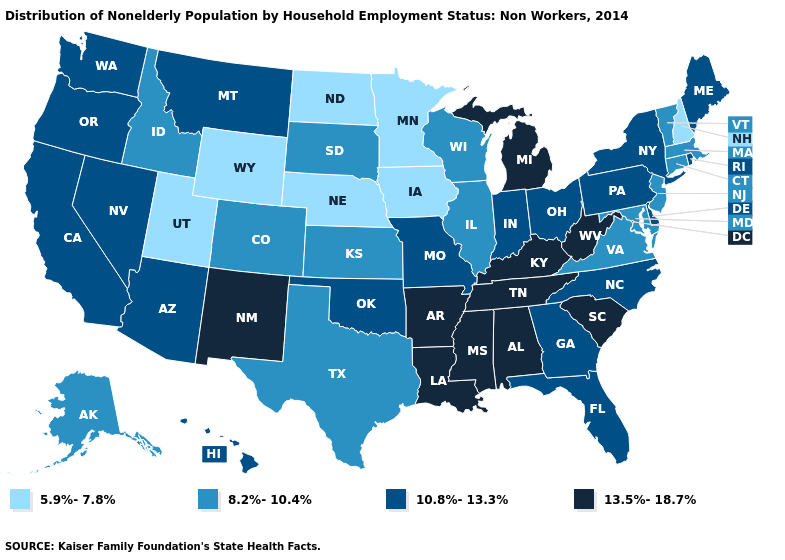Does Delaware have the same value as Arkansas?
Short answer required. No. Which states have the highest value in the USA?
Short answer required. Alabama, Arkansas, Kentucky, Louisiana, Michigan, Mississippi, New Mexico, South Carolina, Tennessee, West Virginia. Does Mississippi have the highest value in the USA?
Quick response, please. Yes. What is the highest value in the USA?
Concise answer only. 13.5%-18.7%. Does the first symbol in the legend represent the smallest category?
Be succinct. Yes. Name the states that have a value in the range 13.5%-18.7%?
Be succinct. Alabama, Arkansas, Kentucky, Louisiana, Michigan, Mississippi, New Mexico, South Carolina, Tennessee, West Virginia. Among the states that border Michigan , which have the highest value?
Write a very short answer. Indiana, Ohio. What is the lowest value in the USA?
Short answer required. 5.9%-7.8%. Name the states that have a value in the range 13.5%-18.7%?
Keep it brief. Alabama, Arkansas, Kentucky, Louisiana, Michigan, Mississippi, New Mexico, South Carolina, Tennessee, West Virginia. How many symbols are there in the legend?
Write a very short answer. 4. What is the lowest value in the Northeast?
Quick response, please. 5.9%-7.8%. Among the states that border Delaware , which have the highest value?
Short answer required. Pennsylvania. What is the highest value in the Northeast ?
Quick response, please. 10.8%-13.3%. What is the value of Colorado?
Short answer required. 8.2%-10.4%. Name the states that have a value in the range 10.8%-13.3%?
Give a very brief answer. Arizona, California, Delaware, Florida, Georgia, Hawaii, Indiana, Maine, Missouri, Montana, Nevada, New York, North Carolina, Ohio, Oklahoma, Oregon, Pennsylvania, Rhode Island, Washington. 